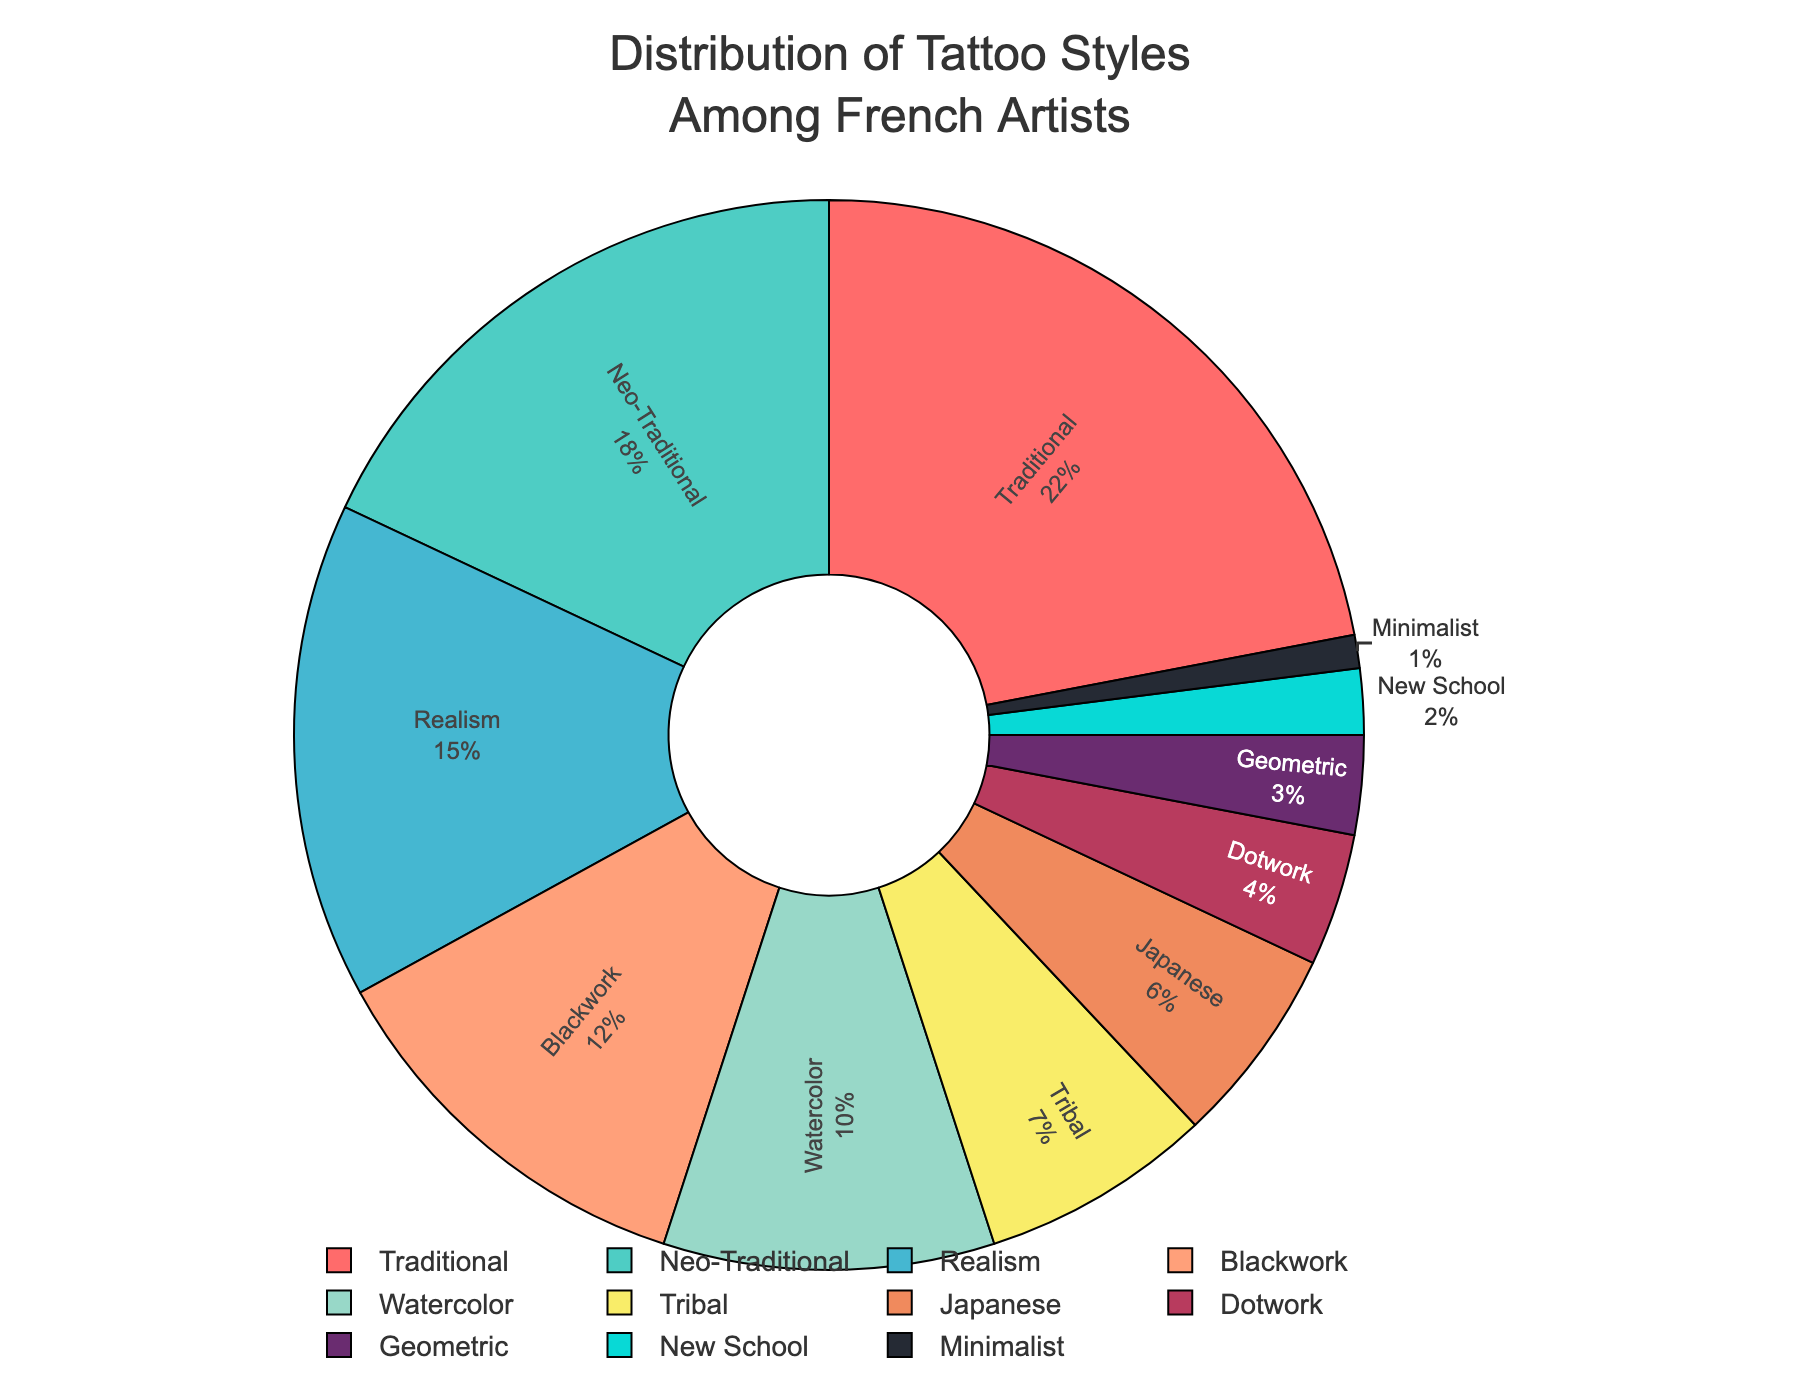Which tattoo style is the most popular among French tattoo artists? The most popular style is identified by the largest section of the pie chart. Traditional style has the largest percentage with 22%.
Answer: Traditional Which tattoo style is the least popular among French tattoo artists? The least popular style is identified by the smallest section of the pie chart. Minimalist style has the smallest percentage with 1%.
Answer: Minimalist What is the combined percentage of Traditional and Neo-Traditional styles? Add the percentages of Traditional (22%) and Neo-Traditional (18%). 22 + 18 = 40
Answer: 40% How much more popular is Realism compared to Geometric style? Subtract the percentage of Geometric style (3%) from Realism style (15%). 15 - 3 = 12
Answer: 12% What percentage of the tattoo styles are represented by Realism, Blackwork, and Watercolor combined? Add the percentages of Realism (15%), Blackwork (12%), and Watercolor (10%). 15 + 12 + 10 = 37
Answer: 37% If you merge the percentages of Tribal and Japanese styles, would they surpass the percentage of Traditional style? Add the percentages of Tribal (7%) and Japanese (6%), then compare the result to Traditional style (22%). 7 + 6 = 13, which is less than 22.
Answer: No How many more percentage points does Traditional have over New School? Subtract the percentage of New School (2%) from Traditional (22%). 22 - 2 = 20
Answer: 20 What percentage do the bottom three styles (Dotwork, Geometric, New School) represent together? Add the percentages of Dotwork (4%), Geometric (3%), and New School (2%). 4 + 3 + 2 = 9
Answer: 9% Which style has a percentage more than double that of Dotwork? Double the percentage of Dotwork (4%): 4 * 2 = 8. Identify the styles with a percentage greater than 8%. Both Traditional (22%) and Neo-Traditional (18%) are well above this threshold.
Answer: Traditional and Neo-Traditional How does the percentage of Blackwork compare to Watercolor? Compare the percentage of Blackwork (12%) with Watercolor (10%). Blackwork has a higher percentage than Watercolor.
Answer: Blackwork 